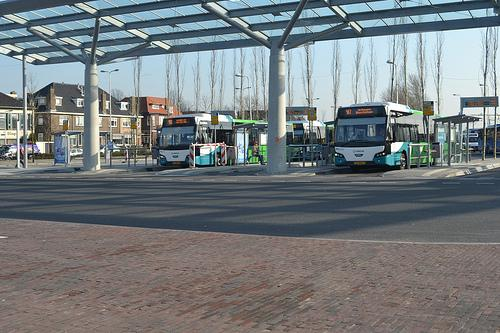Identify and describe the objects supporting the terminal roof. The terminal roof is supported by cement pylons and a structure of metal framework. How many buses are parked at the bus stop, and what's displayed on them? There are three buses parked at the bus stop, each with digital route information signs on them. What type of scenery is observed in the area surrounding the bus terminal? The area around the bus terminal is surrounded by a row of buildings and trees, smooth open ground, and a brick sidewalk. Elaborate on the type of sidewalk nearby the bus terminal. Near the bus terminal, there is a red brick sidewalk that runs along the smooth tarmaced open ground. What's the background view behind the buses at the bus stop? A row of tall thin trees and a clear blue sky form the background view behind the buses at the bus stop. Assess the quality of the image and describe its resolution. The image seems to have high quality, with clear and detailed information about the objects and their positions as well as sizes. What is the main structure present at the bus terminal? The main structure present at the bus terminal is the metal framed bus stop shelter with a transparent roof. Enumerate the different elements you see on the bus passenger shelter. On the bus passenger shelter, an advertisement placard, a metal frame with a transparent roof, and a cement platform are seen. Identify any advertisement in the image and where they are located. There is an advertisement placard on the bus passenger shelter and an advertisement board on the ground near the sidewalk. Mention the different components of a bus that can be seen in the image. Windshield, digital route information sign, license plate, front window, marquee display, headlights, and the roof are visible components of a bus. 